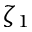<formula> <loc_0><loc_0><loc_500><loc_500>\zeta _ { 1 }</formula> 